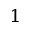Convert formula to latex. <formula><loc_0><loc_0><loc_500><loc_500>^ { 1 }</formula> 